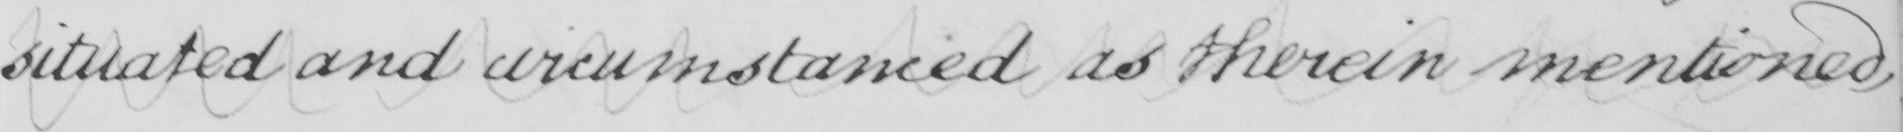Can you read and transcribe this handwriting? situated and circumstanced as therein mentioned , 